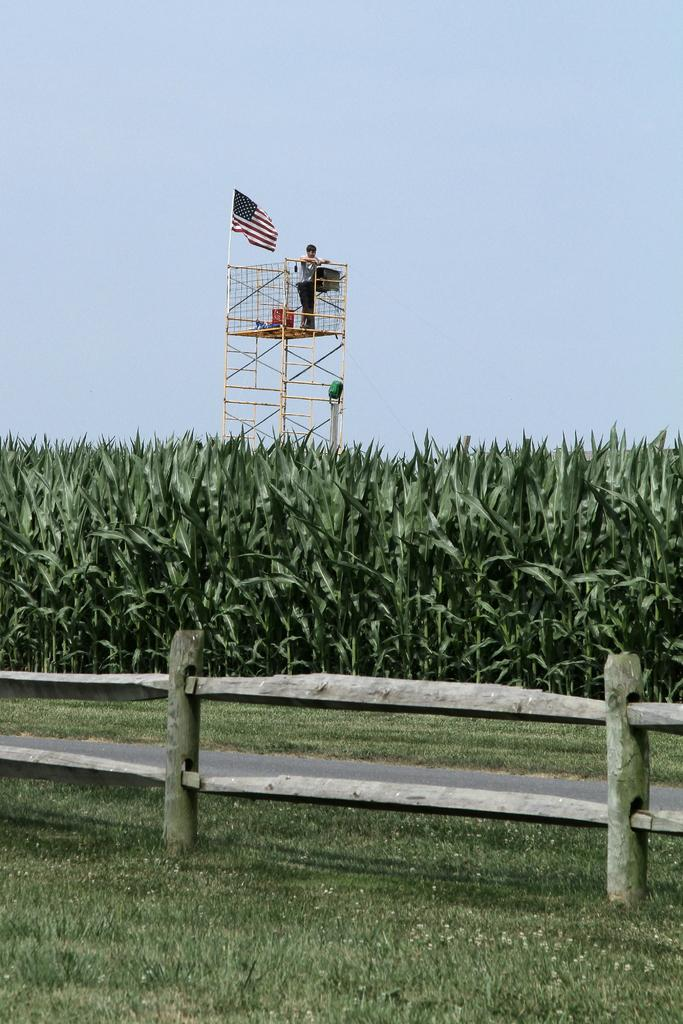What type of fencing is present in the image? There is a wooden fencing in the image. What can be seen in the background of the image? There are plants in the background of the image. What structure is present in the image? There is a tower in the image. What is the person on the tower doing? A person is standing on the tower. What is attached to the tower? There is a flag on the tower. What is visible in the sky in the image? The sky is visible in the image. What type of train can be seen passing through the wooden fencing in the image? There is no train present in the image; it only features a tower, a person, a flag, and a wooden fencing. What tin object is being used by the person on the tower? There is no tin object present in the image, and the person's actions are not described. 